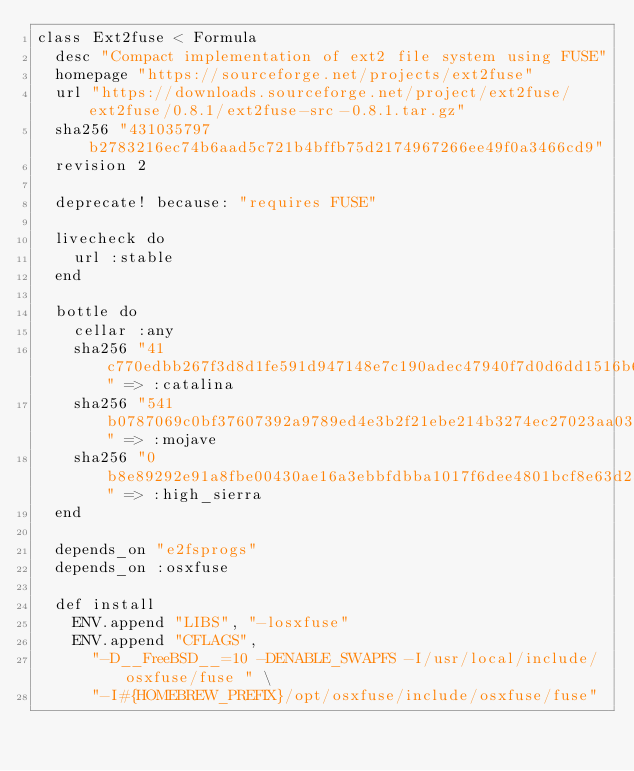<code> <loc_0><loc_0><loc_500><loc_500><_Ruby_>class Ext2fuse < Formula
  desc "Compact implementation of ext2 file system using FUSE"
  homepage "https://sourceforge.net/projects/ext2fuse"
  url "https://downloads.sourceforge.net/project/ext2fuse/ext2fuse/0.8.1/ext2fuse-src-0.8.1.tar.gz"
  sha256 "431035797b2783216ec74b6aad5c721b4bffb75d2174967266ee49f0a3466cd9"
  revision 2

  deprecate! because: "requires FUSE"

  livecheck do
    url :stable
  end

  bottle do
    cellar :any
    sha256 "41c770edbb267f3d8d1fe591d947148e7c190adec47940f7d0d6dd1516b6592c" => :catalina
    sha256 "541b0787069c0bf37607392a9789ed4e3b2f21ebe214b3274ec27023aa03335f" => :mojave
    sha256 "0b8e89292e91a8fbe00430ae16a3ebbfdbba1017f6dee4801bcf8e63d238962f" => :high_sierra
  end

  depends_on "e2fsprogs"
  depends_on :osxfuse

  def install
    ENV.append "LIBS", "-losxfuse"
    ENV.append "CFLAGS",
      "-D__FreeBSD__=10 -DENABLE_SWAPFS -I/usr/local/include/osxfuse/fuse " \
      "-I#{HOMEBREW_PREFIX}/opt/osxfuse/include/osxfuse/fuse"</code> 